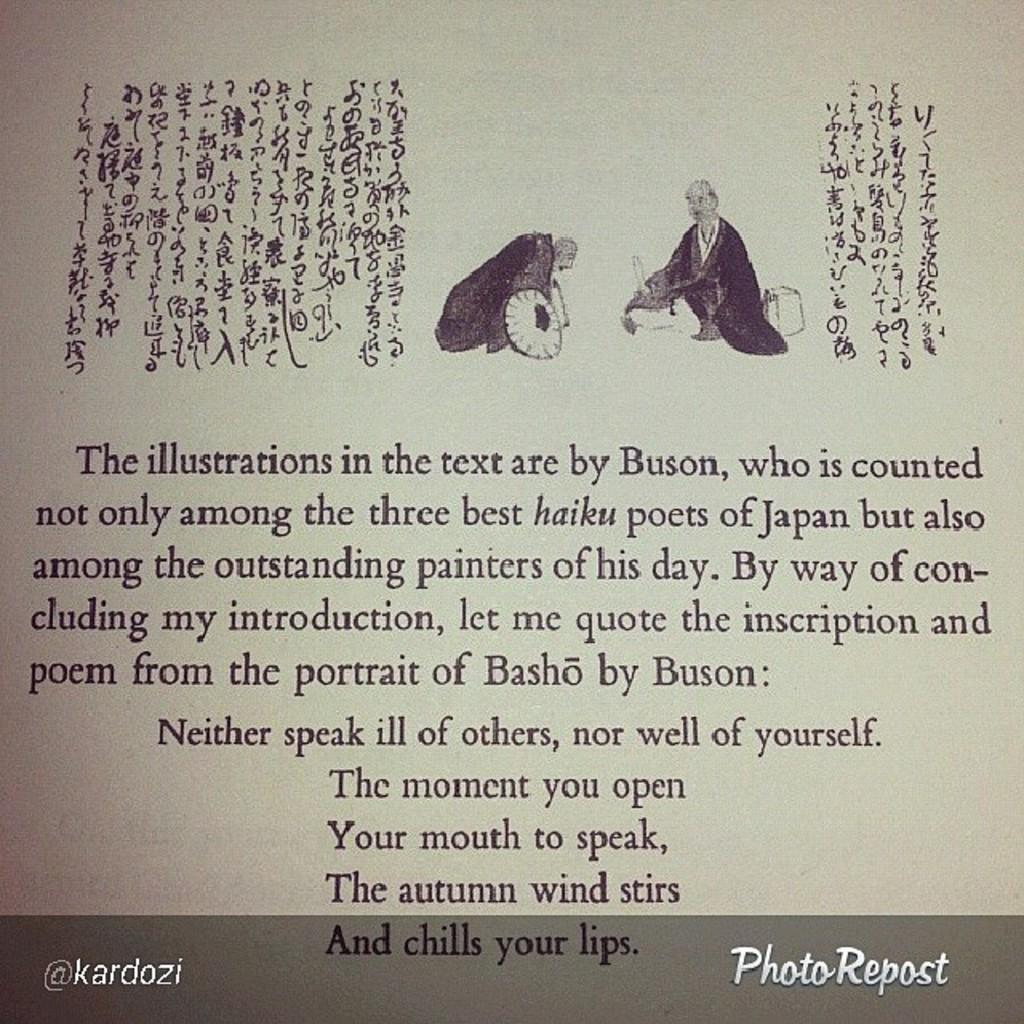<image>
Write a terse but informative summary of the picture. A written page of text about the illustration by Buson. 